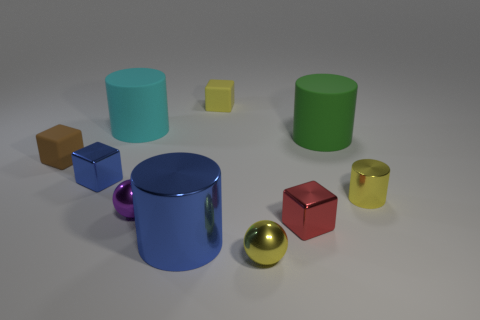How many objects are blue objects or small metal spheres?
Your answer should be very brief. 4. There is a brown matte thing; is its size the same as the yellow thing behind the small brown rubber block?
Offer a terse response. Yes. What is the size of the metallic object right of the large object that is on the right side of the tiny yellow object that is behind the blue metal block?
Keep it short and to the point. Small. Is there a small cylinder?
Keep it short and to the point. Yes. There is a small block that is the same color as the large metal cylinder; what is its material?
Your answer should be compact. Metal. How many big rubber cylinders have the same color as the large metal cylinder?
Your answer should be compact. 0. What number of things are either tiny cubes that are on the left side of the blue metal cube or large rubber objects that are right of the purple ball?
Your answer should be compact. 2. What number of tiny yellow objects are in front of the matte cylinder that is to the right of the tiny purple thing?
Offer a terse response. 2. There is a large cylinder that is made of the same material as the purple ball; what color is it?
Keep it short and to the point. Blue. Are there any green rubber objects of the same size as the yellow block?
Provide a succinct answer. No. 